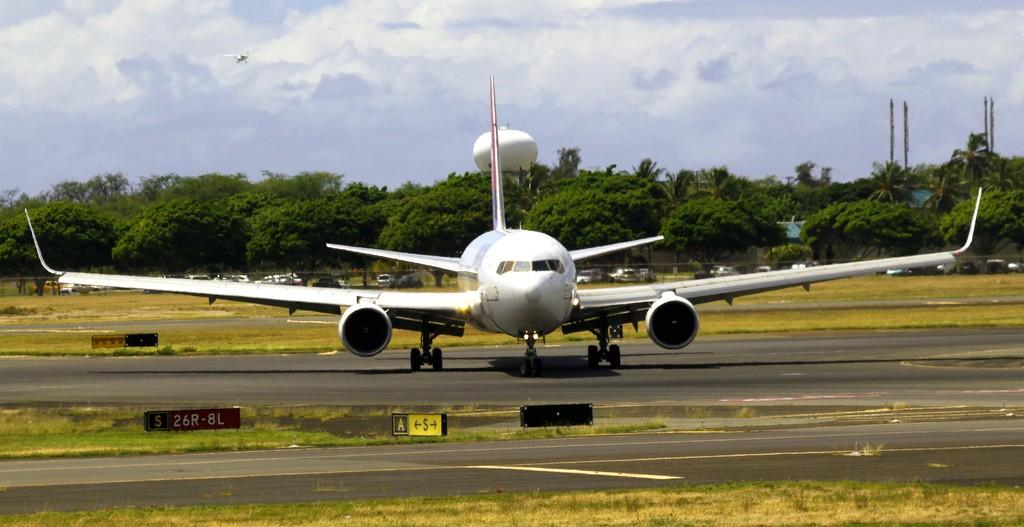<image>
Give a short and clear explanation of the subsequent image. An airplane is sitting on a tarmack with a sign in front of it that says S 26R-8L 